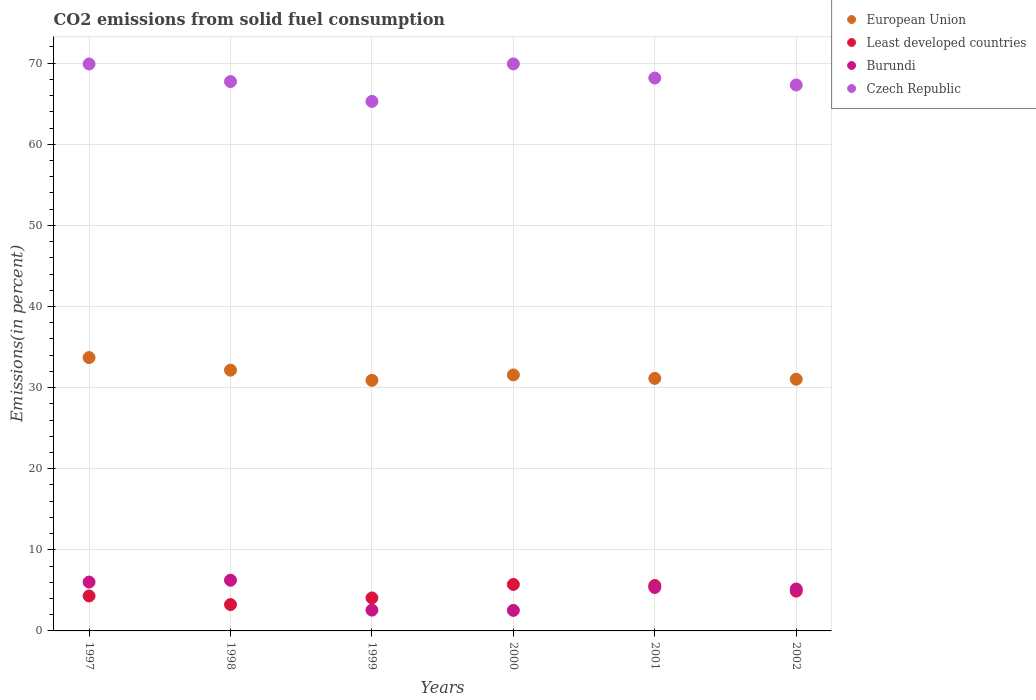How many different coloured dotlines are there?
Provide a short and direct response. 4. What is the total CO2 emitted in Czech Republic in 1997?
Ensure brevity in your answer.  69.9. Across all years, what is the maximum total CO2 emitted in Czech Republic?
Offer a terse response. 69.91. Across all years, what is the minimum total CO2 emitted in Least developed countries?
Provide a succinct answer. 3.25. What is the total total CO2 emitted in European Union in the graph?
Your response must be concise. 190.49. What is the difference between the total CO2 emitted in Least developed countries in 1998 and that in 1999?
Your answer should be compact. -0.82. What is the difference between the total CO2 emitted in Czech Republic in 2002 and the total CO2 emitted in Burundi in 2001?
Provide a succinct answer. 61.96. What is the average total CO2 emitted in European Union per year?
Your answer should be compact. 31.75. In the year 2000, what is the difference between the total CO2 emitted in European Union and total CO2 emitted in Czech Republic?
Your answer should be compact. -38.35. In how many years, is the total CO2 emitted in Czech Republic greater than 66 %?
Keep it short and to the point. 5. What is the ratio of the total CO2 emitted in Czech Republic in 2000 to that in 2002?
Your answer should be very brief. 1.04. What is the difference between the highest and the second highest total CO2 emitted in Least developed countries?
Your response must be concise. 0.13. What is the difference between the highest and the lowest total CO2 emitted in Czech Republic?
Ensure brevity in your answer.  4.62. In how many years, is the total CO2 emitted in Burundi greater than the average total CO2 emitted in Burundi taken over all years?
Offer a very short reply. 4. Is the sum of the total CO2 emitted in European Union in 1999 and 2002 greater than the maximum total CO2 emitted in Burundi across all years?
Keep it short and to the point. Yes. Is it the case that in every year, the sum of the total CO2 emitted in Least developed countries and total CO2 emitted in Burundi  is greater than the sum of total CO2 emitted in Czech Republic and total CO2 emitted in European Union?
Your response must be concise. No. Is the total CO2 emitted in Burundi strictly greater than the total CO2 emitted in Czech Republic over the years?
Your answer should be compact. No. Is the total CO2 emitted in Least developed countries strictly less than the total CO2 emitted in Czech Republic over the years?
Your response must be concise. Yes. Are the values on the major ticks of Y-axis written in scientific E-notation?
Make the answer very short. No. Does the graph contain any zero values?
Provide a short and direct response. No. How many legend labels are there?
Offer a terse response. 4. What is the title of the graph?
Offer a terse response. CO2 emissions from solid fuel consumption. What is the label or title of the Y-axis?
Make the answer very short. Emissions(in percent). What is the Emissions(in percent) in European Union in 1997?
Give a very brief answer. 33.7. What is the Emissions(in percent) in Least developed countries in 1997?
Keep it short and to the point. 4.31. What is the Emissions(in percent) in Burundi in 1997?
Ensure brevity in your answer.  6.02. What is the Emissions(in percent) of Czech Republic in 1997?
Offer a very short reply. 69.9. What is the Emissions(in percent) in European Union in 1998?
Your answer should be very brief. 32.15. What is the Emissions(in percent) in Least developed countries in 1998?
Your response must be concise. 3.25. What is the Emissions(in percent) of Burundi in 1998?
Make the answer very short. 6.25. What is the Emissions(in percent) in Czech Republic in 1998?
Your answer should be very brief. 67.73. What is the Emissions(in percent) in European Union in 1999?
Give a very brief answer. 30.9. What is the Emissions(in percent) in Least developed countries in 1999?
Ensure brevity in your answer.  4.07. What is the Emissions(in percent) of Burundi in 1999?
Give a very brief answer. 2.56. What is the Emissions(in percent) in Czech Republic in 1999?
Your answer should be very brief. 65.29. What is the Emissions(in percent) of European Union in 2000?
Offer a very short reply. 31.56. What is the Emissions(in percent) of Least developed countries in 2000?
Your response must be concise. 5.73. What is the Emissions(in percent) in Burundi in 2000?
Provide a succinct answer. 2.53. What is the Emissions(in percent) of Czech Republic in 2000?
Offer a very short reply. 69.91. What is the Emissions(in percent) in European Union in 2001?
Ensure brevity in your answer.  31.14. What is the Emissions(in percent) in Least developed countries in 2001?
Ensure brevity in your answer.  5.6. What is the Emissions(in percent) in Burundi in 2001?
Your answer should be compact. 5.36. What is the Emissions(in percent) of Czech Republic in 2001?
Make the answer very short. 68.17. What is the Emissions(in percent) of European Union in 2002?
Provide a short and direct response. 31.04. What is the Emissions(in percent) of Least developed countries in 2002?
Make the answer very short. 4.91. What is the Emissions(in percent) in Burundi in 2002?
Offer a terse response. 5.17. What is the Emissions(in percent) of Czech Republic in 2002?
Your answer should be compact. 67.31. Across all years, what is the maximum Emissions(in percent) of European Union?
Ensure brevity in your answer.  33.7. Across all years, what is the maximum Emissions(in percent) in Least developed countries?
Ensure brevity in your answer.  5.73. Across all years, what is the maximum Emissions(in percent) of Burundi?
Provide a succinct answer. 6.25. Across all years, what is the maximum Emissions(in percent) of Czech Republic?
Your answer should be compact. 69.91. Across all years, what is the minimum Emissions(in percent) in European Union?
Make the answer very short. 30.9. Across all years, what is the minimum Emissions(in percent) in Least developed countries?
Give a very brief answer. 3.25. Across all years, what is the minimum Emissions(in percent) of Burundi?
Your answer should be very brief. 2.53. Across all years, what is the minimum Emissions(in percent) in Czech Republic?
Your answer should be compact. 65.29. What is the total Emissions(in percent) of European Union in the graph?
Your response must be concise. 190.49. What is the total Emissions(in percent) of Least developed countries in the graph?
Keep it short and to the point. 27.86. What is the total Emissions(in percent) in Burundi in the graph?
Give a very brief answer. 27.9. What is the total Emissions(in percent) of Czech Republic in the graph?
Ensure brevity in your answer.  408.32. What is the difference between the Emissions(in percent) of European Union in 1997 and that in 1998?
Your answer should be compact. 1.55. What is the difference between the Emissions(in percent) in Least developed countries in 1997 and that in 1998?
Your response must be concise. 1.06. What is the difference between the Emissions(in percent) of Burundi in 1997 and that in 1998?
Give a very brief answer. -0.23. What is the difference between the Emissions(in percent) of Czech Republic in 1997 and that in 1998?
Give a very brief answer. 2.17. What is the difference between the Emissions(in percent) in European Union in 1997 and that in 1999?
Provide a succinct answer. 2.8. What is the difference between the Emissions(in percent) in Least developed countries in 1997 and that in 1999?
Offer a very short reply. 0.25. What is the difference between the Emissions(in percent) of Burundi in 1997 and that in 1999?
Keep it short and to the point. 3.46. What is the difference between the Emissions(in percent) in Czech Republic in 1997 and that in 1999?
Your answer should be very brief. 4.61. What is the difference between the Emissions(in percent) of European Union in 1997 and that in 2000?
Your response must be concise. 2.14. What is the difference between the Emissions(in percent) of Least developed countries in 1997 and that in 2000?
Provide a succinct answer. -1.42. What is the difference between the Emissions(in percent) in Burundi in 1997 and that in 2000?
Your answer should be compact. 3.49. What is the difference between the Emissions(in percent) of Czech Republic in 1997 and that in 2000?
Your response must be concise. -0.01. What is the difference between the Emissions(in percent) of European Union in 1997 and that in 2001?
Keep it short and to the point. 2.56. What is the difference between the Emissions(in percent) of Least developed countries in 1997 and that in 2001?
Provide a short and direct response. -1.29. What is the difference between the Emissions(in percent) of Burundi in 1997 and that in 2001?
Provide a short and direct response. 0.67. What is the difference between the Emissions(in percent) of Czech Republic in 1997 and that in 2001?
Offer a very short reply. 1.73. What is the difference between the Emissions(in percent) in European Union in 1997 and that in 2002?
Your answer should be very brief. 2.67. What is the difference between the Emissions(in percent) of Least developed countries in 1997 and that in 2002?
Give a very brief answer. -0.6. What is the difference between the Emissions(in percent) of Burundi in 1997 and that in 2002?
Make the answer very short. 0.85. What is the difference between the Emissions(in percent) of Czech Republic in 1997 and that in 2002?
Make the answer very short. 2.59. What is the difference between the Emissions(in percent) of European Union in 1998 and that in 1999?
Make the answer very short. 1.26. What is the difference between the Emissions(in percent) in Least developed countries in 1998 and that in 1999?
Give a very brief answer. -0.82. What is the difference between the Emissions(in percent) of Burundi in 1998 and that in 1999?
Offer a very short reply. 3.69. What is the difference between the Emissions(in percent) of Czech Republic in 1998 and that in 1999?
Your answer should be very brief. 2.45. What is the difference between the Emissions(in percent) in European Union in 1998 and that in 2000?
Your answer should be very brief. 0.59. What is the difference between the Emissions(in percent) in Least developed countries in 1998 and that in 2000?
Give a very brief answer. -2.48. What is the difference between the Emissions(in percent) in Burundi in 1998 and that in 2000?
Give a very brief answer. 3.72. What is the difference between the Emissions(in percent) in Czech Republic in 1998 and that in 2000?
Offer a very short reply. -2.18. What is the difference between the Emissions(in percent) in European Union in 1998 and that in 2001?
Your response must be concise. 1.02. What is the difference between the Emissions(in percent) of Least developed countries in 1998 and that in 2001?
Offer a terse response. -2.35. What is the difference between the Emissions(in percent) in Burundi in 1998 and that in 2001?
Make the answer very short. 0.89. What is the difference between the Emissions(in percent) in Czech Republic in 1998 and that in 2001?
Your answer should be very brief. -0.44. What is the difference between the Emissions(in percent) of European Union in 1998 and that in 2002?
Provide a short and direct response. 1.12. What is the difference between the Emissions(in percent) in Least developed countries in 1998 and that in 2002?
Offer a terse response. -1.66. What is the difference between the Emissions(in percent) of Burundi in 1998 and that in 2002?
Ensure brevity in your answer.  1.08. What is the difference between the Emissions(in percent) in Czech Republic in 1998 and that in 2002?
Keep it short and to the point. 0.42. What is the difference between the Emissions(in percent) of Least developed countries in 1999 and that in 2000?
Provide a succinct answer. -1.66. What is the difference between the Emissions(in percent) of Burundi in 1999 and that in 2000?
Provide a short and direct response. 0.03. What is the difference between the Emissions(in percent) in Czech Republic in 1999 and that in 2000?
Keep it short and to the point. -4.62. What is the difference between the Emissions(in percent) of European Union in 1999 and that in 2001?
Offer a terse response. -0.24. What is the difference between the Emissions(in percent) in Least developed countries in 1999 and that in 2001?
Offer a terse response. -1.53. What is the difference between the Emissions(in percent) of Burundi in 1999 and that in 2001?
Make the answer very short. -2.79. What is the difference between the Emissions(in percent) of Czech Republic in 1999 and that in 2001?
Keep it short and to the point. -2.88. What is the difference between the Emissions(in percent) in European Union in 1999 and that in 2002?
Offer a very short reply. -0.14. What is the difference between the Emissions(in percent) of Least developed countries in 1999 and that in 2002?
Keep it short and to the point. -0.84. What is the difference between the Emissions(in percent) in Burundi in 1999 and that in 2002?
Your response must be concise. -2.61. What is the difference between the Emissions(in percent) of Czech Republic in 1999 and that in 2002?
Make the answer very short. -2.03. What is the difference between the Emissions(in percent) of European Union in 2000 and that in 2001?
Offer a terse response. 0.43. What is the difference between the Emissions(in percent) in Least developed countries in 2000 and that in 2001?
Make the answer very short. 0.13. What is the difference between the Emissions(in percent) of Burundi in 2000 and that in 2001?
Give a very brief answer. -2.83. What is the difference between the Emissions(in percent) of Czech Republic in 2000 and that in 2001?
Provide a short and direct response. 1.74. What is the difference between the Emissions(in percent) of European Union in 2000 and that in 2002?
Offer a very short reply. 0.53. What is the difference between the Emissions(in percent) of Least developed countries in 2000 and that in 2002?
Offer a very short reply. 0.82. What is the difference between the Emissions(in percent) in Burundi in 2000 and that in 2002?
Your answer should be very brief. -2.64. What is the difference between the Emissions(in percent) in Czech Republic in 2000 and that in 2002?
Keep it short and to the point. 2.6. What is the difference between the Emissions(in percent) of European Union in 2001 and that in 2002?
Keep it short and to the point. 0.1. What is the difference between the Emissions(in percent) in Least developed countries in 2001 and that in 2002?
Provide a short and direct response. 0.69. What is the difference between the Emissions(in percent) of Burundi in 2001 and that in 2002?
Make the answer very short. 0.18. What is the difference between the Emissions(in percent) in Czech Republic in 2001 and that in 2002?
Your answer should be compact. 0.86. What is the difference between the Emissions(in percent) in European Union in 1997 and the Emissions(in percent) in Least developed countries in 1998?
Keep it short and to the point. 30.45. What is the difference between the Emissions(in percent) in European Union in 1997 and the Emissions(in percent) in Burundi in 1998?
Your response must be concise. 27.45. What is the difference between the Emissions(in percent) of European Union in 1997 and the Emissions(in percent) of Czech Republic in 1998?
Offer a very short reply. -34.03. What is the difference between the Emissions(in percent) of Least developed countries in 1997 and the Emissions(in percent) of Burundi in 1998?
Your answer should be very brief. -1.94. What is the difference between the Emissions(in percent) of Least developed countries in 1997 and the Emissions(in percent) of Czech Republic in 1998?
Your answer should be very brief. -63.42. What is the difference between the Emissions(in percent) of Burundi in 1997 and the Emissions(in percent) of Czech Republic in 1998?
Your response must be concise. -61.71. What is the difference between the Emissions(in percent) in European Union in 1997 and the Emissions(in percent) in Least developed countries in 1999?
Give a very brief answer. 29.64. What is the difference between the Emissions(in percent) of European Union in 1997 and the Emissions(in percent) of Burundi in 1999?
Keep it short and to the point. 31.14. What is the difference between the Emissions(in percent) of European Union in 1997 and the Emissions(in percent) of Czech Republic in 1999?
Give a very brief answer. -31.59. What is the difference between the Emissions(in percent) in Least developed countries in 1997 and the Emissions(in percent) in Burundi in 1999?
Offer a very short reply. 1.75. What is the difference between the Emissions(in percent) in Least developed countries in 1997 and the Emissions(in percent) in Czech Republic in 1999?
Provide a short and direct response. -60.98. What is the difference between the Emissions(in percent) of Burundi in 1997 and the Emissions(in percent) of Czech Republic in 1999?
Make the answer very short. -59.26. What is the difference between the Emissions(in percent) of European Union in 1997 and the Emissions(in percent) of Least developed countries in 2000?
Give a very brief answer. 27.97. What is the difference between the Emissions(in percent) of European Union in 1997 and the Emissions(in percent) of Burundi in 2000?
Provide a succinct answer. 31.17. What is the difference between the Emissions(in percent) in European Union in 1997 and the Emissions(in percent) in Czech Republic in 2000?
Ensure brevity in your answer.  -36.21. What is the difference between the Emissions(in percent) of Least developed countries in 1997 and the Emissions(in percent) of Burundi in 2000?
Make the answer very short. 1.78. What is the difference between the Emissions(in percent) in Least developed countries in 1997 and the Emissions(in percent) in Czech Republic in 2000?
Provide a succinct answer. -65.6. What is the difference between the Emissions(in percent) of Burundi in 1997 and the Emissions(in percent) of Czech Republic in 2000?
Provide a short and direct response. -63.89. What is the difference between the Emissions(in percent) in European Union in 1997 and the Emissions(in percent) in Least developed countries in 2001?
Your response must be concise. 28.1. What is the difference between the Emissions(in percent) in European Union in 1997 and the Emissions(in percent) in Burundi in 2001?
Your answer should be compact. 28.35. What is the difference between the Emissions(in percent) in European Union in 1997 and the Emissions(in percent) in Czech Republic in 2001?
Offer a very short reply. -34.47. What is the difference between the Emissions(in percent) in Least developed countries in 1997 and the Emissions(in percent) in Burundi in 2001?
Your answer should be compact. -1.05. What is the difference between the Emissions(in percent) of Least developed countries in 1997 and the Emissions(in percent) of Czech Republic in 2001?
Provide a succinct answer. -63.86. What is the difference between the Emissions(in percent) in Burundi in 1997 and the Emissions(in percent) in Czech Republic in 2001?
Offer a terse response. -62.15. What is the difference between the Emissions(in percent) of European Union in 1997 and the Emissions(in percent) of Least developed countries in 2002?
Provide a succinct answer. 28.79. What is the difference between the Emissions(in percent) in European Union in 1997 and the Emissions(in percent) in Burundi in 2002?
Ensure brevity in your answer.  28.53. What is the difference between the Emissions(in percent) of European Union in 1997 and the Emissions(in percent) of Czech Republic in 2002?
Provide a short and direct response. -33.61. What is the difference between the Emissions(in percent) of Least developed countries in 1997 and the Emissions(in percent) of Burundi in 2002?
Offer a terse response. -0.86. What is the difference between the Emissions(in percent) of Least developed countries in 1997 and the Emissions(in percent) of Czech Republic in 2002?
Give a very brief answer. -63. What is the difference between the Emissions(in percent) of Burundi in 1997 and the Emissions(in percent) of Czech Republic in 2002?
Give a very brief answer. -61.29. What is the difference between the Emissions(in percent) of European Union in 1998 and the Emissions(in percent) of Least developed countries in 1999?
Offer a very short reply. 28.09. What is the difference between the Emissions(in percent) in European Union in 1998 and the Emissions(in percent) in Burundi in 1999?
Your response must be concise. 29.59. What is the difference between the Emissions(in percent) in European Union in 1998 and the Emissions(in percent) in Czech Republic in 1999?
Keep it short and to the point. -33.14. What is the difference between the Emissions(in percent) in Least developed countries in 1998 and the Emissions(in percent) in Burundi in 1999?
Offer a terse response. 0.68. What is the difference between the Emissions(in percent) of Least developed countries in 1998 and the Emissions(in percent) of Czech Republic in 1999?
Your answer should be compact. -62.04. What is the difference between the Emissions(in percent) in Burundi in 1998 and the Emissions(in percent) in Czech Republic in 1999?
Provide a succinct answer. -59.04. What is the difference between the Emissions(in percent) in European Union in 1998 and the Emissions(in percent) in Least developed countries in 2000?
Make the answer very short. 26.42. What is the difference between the Emissions(in percent) of European Union in 1998 and the Emissions(in percent) of Burundi in 2000?
Your answer should be very brief. 29.62. What is the difference between the Emissions(in percent) of European Union in 1998 and the Emissions(in percent) of Czech Republic in 2000?
Offer a very short reply. -37.76. What is the difference between the Emissions(in percent) in Least developed countries in 1998 and the Emissions(in percent) in Burundi in 2000?
Offer a terse response. 0.72. What is the difference between the Emissions(in percent) in Least developed countries in 1998 and the Emissions(in percent) in Czech Republic in 2000?
Make the answer very short. -66.67. What is the difference between the Emissions(in percent) in Burundi in 1998 and the Emissions(in percent) in Czech Republic in 2000?
Offer a terse response. -63.66. What is the difference between the Emissions(in percent) of European Union in 1998 and the Emissions(in percent) of Least developed countries in 2001?
Keep it short and to the point. 26.55. What is the difference between the Emissions(in percent) of European Union in 1998 and the Emissions(in percent) of Burundi in 2001?
Make the answer very short. 26.8. What is the difference between the Emissions(in percent) of European Union in 1998 and the Emissions(in percent) of Czech Republic in 2001?
Give a very brief answer. -36.02. What is the difference between the Emissions(in percent) of Least developed countries in 1998 and the Emissions(in percent) of Burundi in 2001?
Provide a succinct answer. -2.11. What is the difference between the Emissions(in percent) of Least developed countries in 1998 and the Emissions(in percent) of Czech Republic in 2001?
Offer a terse response. -64.92. What is the difference between the Emissions(in percent) in Burundi in 1998 and the Emissions(in percent) in Czech Republic in 2001?
Give a very brief answer. -61.92. What is the difference between the Emissions(in percent) of European Union in 1998 and the Emissions(in percent) of Least developed countries in 2002?
Keep it short and to the point. 27.25. What is the difference between the Emissions(in percent) in European Union in 1998 and the Emissions(in percent) in Burundi in 2002?
Provide a short and direct response. 26.98. What is the difference between the Emissions(in percent) of European Union in 1998 and the Emissions(in percent) of Czech Republic in 2002?
Offer a very short reply. -35.16. What is the difference between the Emissions(in percent) of Least developed countries in 1998 and the Emissions(in percent) of Burundi in 2002?
Your response must be concise. -1.92. What is the difference between the Emissions(in percent) in Least developed countries in 1998 and the Emissions(in percent) in Czech Republic in 2002?
Ensure brevity in your answer.  -64.07. What is the difference between the Emissions(in percent) of Burundi in 1998 and the Emissions(in percent) of Czech Republic in 2002?
Offer a terse response. -61.06. What is the difference between the Emissions(in percent) of European Union in 1999 and the Emissions(in percent) of Least developed countries in 2000?
Give a very brief answer. 25.17. What is the difference between the Emissions(in percent) of European Union in 1999 and the Emissions(in percent) of Burundi in 2000?
Provide a succinct answer. 28.37. What is the difference between the Emissions(in percent) of European Union in 1999 and the Emissions(in percent) of Czech Republic in 2000?
Keep it short and to the point. -39.02. What is the difference between the Emissions(in percent) in Least developed countries in 1999 and the Emissions(in percent) in Burundi in 2000?
Offer a very short reply. 1.53. What is the difference between the Emissions(in percent) of Least developed countries in 1999 and the Emissions(in percent) of Czech Republic in 2000?
Provide a short and direct response. -65.85. What is the difference between the Emissions(in percent) in Burundi in 1999 and the Emissions(in percent) in Czech Republic in 2000?
Provide a short and direct response. -67.35. What is the difference between the Emissions(in percent) of European Union in 1999 and the Emissions(in percent) of Least developed countries in 2001?
Provide a short and direct response. 25.3. What is the difference between the Emissions(in percent) in European Union in 1999 and the Emissions(in percent) in Burundi in 2001?
Your answer should be very brief. 25.54. What is the difference between the Emissions(in percent) in European Union in 1999 and the Emissions(in percent) in Czech Republic in 2001?
Provide a short and direct response. -37.27. What is the difference between the Emissions(in percent) in Least developed countries in 1999 and the Emissions(in percent) in Burundi in 2001?
Offer a terse response. -1.29. What is the difference between the Emissions(in percent) of Least developed countries in 1999 and the Emissions(in percent) of Czech Republic in 2001?
Your answer should be compact. -64.11. What is the difference between the Emissions(in percent) in Burundi in 1999 and the Emissions(in percent) in Czech Republic in 2001?
Ensure brevity in your answer.  -65.61. What is the difference between the Emissions(in percent) in European Union in 1999 and the Emissions(in percent) in Least developed countries in 2002?
Provide a succinct answer. 25.99. What is the difference between the Emissions(in percent) in European Union in 1999 and the Emissions(in percent) in Burundi in 2002?
Keep it short and to the point. 25.73. What is the difference between the Emissions(in percent) of European Union in 1999 and the Emissions(in percent) of Czech Republic in 2002?
Offer a terse response. -36.42. What is the difference between the Emissions(in percent) in Least developed countries in 1999 and the Emissions(in percent) in Burundi in 2002?
Your answer should be compact. -1.11. What is the difference between the Emissions(in percent) in Least developed countries in 1999 and the Emissions(in percent) in Czech Republic in 2002?
Your answer should be very brief. -63.25. What is the difference between the Emissions(in percent) in Burundi in 1999 and the Emissions(in percent) in Czech Republic in 2002?
Make the answer very short. -64.75. What is the difference between the Emissions(in percent) in European Union in 2000 and the Emissions(in percent) in Least developed countries in 2001?
Provide a short and direct response. 25.97. What is the difference between the Emissions(in percent) in European Union in 2000 and the Emissions(in percent) in Burundi in 2001?
Keep it short and to the point. 26.21. What is the difference between the Emissions(in percent) in European Union in 2000 and the Emissions(in percent) in Czech Republic in 2001?
Your answer should be very brief. -36.61. What is the difference between the Emissions(in percent) in Least developed countries in 2000 and the Emissions(in percent) in Burundi in 2001?
Give a very brief answer. 0.37. What is the difference between the Emissions(in percent) in Least developed countries in 2000 and the Emissions(in percent) in Czech Republic in 2001?
Keep it short and to the point. -62.44. What is the difference between the Emissions(in percent) in Burundi in 2000 and the Emissions(in percent) in Czech Republic in 2001?
Give a very brief answer. -65.64. What is the difference between the Emissions(in percent) in European Union in 2000 and the Emissions(in percent) in Least developed countries in 2002?
Ensure brevity in your answer.  26.66. What is the difference between the Emissions(in percent) in European Union in 2000 and the Emissions(in percent) in Burundi in 2002?
Your response must be concise. 26.39. What is the difference between the Emissions(in percent) of European Union in 2000 and the Emissions(in percent) of Czech Republic in 2002?
Provide a succinct answer. -35.75. What is the difference between the Emissions(in percent) of Least developed countries in 2000 and the Emissions(in percent) of Burundi in 2002?
Provide a succinct answer. 0.56. What is the difference between the Emissions(in percent) of Least developed countries in 2000 and the Emissions(in percent) of Czech Republic in 2002?
Offer a very short reply. -61.59. What is the difference between the Emissions(in percent) of Burundi in 2000 and the Emissions(in percent) of Czech Republic in 2002?
Give a very brief answer. -64.78. What is the difference between the Emissions(in percent) of European Union in 2001 and the Emissions(in percent) of Least developed countries in 2002?
Make the answer very short. 26.23. What is the difference between the Emissions(in percent) of European Union in 2001 and the Emissions(in percent) of Burundi in 2002?
Your answer should be compact. 25.97. What is the difference between the Emissions(in percent) in European Union in 2001 and the Emissions(in percent) in Czech Republic in 2002?
Your answer should be very brief. -36.18. What is the difference between the Emissions(in percent) in Least developed countries in 2001 and the Emissions(in percent) in Burundi in 2002?
Make the answer very short. 0.43. What is the difference between the Emissions(in percent) of Least developed countries in 2001 and the Emissions(in percent) of Czech Republic in 2002?
Give a very brief answer. -61.72. What is the difference between the Emissions(in percent) of Burundi in 2001 and the Emissions(in percent) of Czech Republic in 2002?
Keep it short and to the point. -61.96. What is the average Emissions(in percent) of European Union per year?
Your answer should be very brief. 31.75. What is the average Emissions(in percent) of Least developed countries per year?
Provide a succinct answer. 4.64. What is the average Emissions(in percent) in Burundi per year?
Offer a terse response. 4.65. What is the average Emissions(in percent) in Czech Republic per year?
Give a very brief answer. 68.05. In the year 1997, what is the difference between the Emissions(in percent) in European Union and Emissions(in percent) in Least developed countries?
Your answer should be compact. 29.39. In the year 1997, what is the difference between the Emissions(in percent) in European Union and Emissions(in percent) in Burundi?
Keep it short and to the point. 27.68. In the year 1997, what is the difference between the Emissions(in percent) in European Union and Emissions(in percent) in Czech Republic?
Offer a very short reply. -36.2. In the year 1997, what is the difference between the Emissions(in percent) of Least developed countries and Emissions(in percent) of Burundi?
Provide a short and direct response. -1.71. In the year 1997, what is the difference between the Emissions(in percent) in Least developed countries and Emissions(in percent) in Czech Republic?
Give a very brief answer. -65.59. In the year 1997, what is the difference between the Emissions(in percent) of Burundi and Emissions(in percent) of Czech Republic?
Your response must be concise. -63.88. In the year 1998, what is the difference between the Emissions(in percent) of European Union and Emissions(in percent) of Least developed countries?
Provide a succinct answer. 28.91. In the year 1998, what is the difference between the Emissions(in percent) in European Union and Emissions(in percent) in Burundi?
Ensure brevity in your answer.  25.9. In the year 1998, what is the difference between the Emissions(in percent) in European Union and Emissions(in percent) in Czech Republic?
Offer a terse response. -35.58. In the year 1998, what is the difference between the Emissions(in percent) in Least developed countries and Emissions(in percent) in Burundi?
Offer a terse response. -3. In the year 1998, what is the difference between the Emissions(in percent) of Least developed countries and Emissions(in percent) of Czech Republic?
Your answer should be very brief. -64.49. In the year 1998, what is the difference between the Emissions(in percent) of Burundi and Emissions(in percent) of Czech Republic?
Give a very brief answer. -61.48. In the year 1999, what is the difference between the Emissions(in percent) in European Union and Emissions(in percent) in Least developed countries?
Your answer should be compact. 26.83. In the year 1999, what is the difference between the Emissions(in percent) in European Union and Emissions(in percent) in Burundi?
Offer a very short reply. 28.33. In the year 1999, what is the difference between the Emissions(in percent) of European Union and Emissions(in percent) of Czech Republic?
Ensure brevity in your answer.  -34.39. In the year 1999, what is the difference between the Emissions(in percent) of Least developed countries and Emissions(in percent) of Burundi?
Keep it short and to the point. 1.5. In the year 1999, what is the difference between the Emissions(in percent) of Least developed countries and Emissions(in percent) of Czech Republic?
Keep it short and to the point. -61.22. In the year 1999, what is the difference between the Emissions(in percent) of Burundi and Emissions(in percent) of Czech Republic?
Your answer should be very brief. -62.72. In the year 2000, what is the difference between the Emissions(in percent) in European Union and Emissions(in percent) in Least developed countries?
Keep it short and to the point. 25.83. In the year 2000, what is the difference between the Emissions(in percent) of European Union and Emissions(in percent) of Burundi?
Your response must be concise. 29.03. In the year 2000, what is the difference between the Emissions(in percent) in European Union and Emissions(in percent) in Czech Republic?
Offer a very short reply. -38.35. In the year 2000, what is the difference between the Emissions(in percent) in Least developed countries and Emissions(in percent) in Burundi?
Your answer should be very brief. 3.2. In the year 2000, what is the difference between the Emissions(in percent) of Least developed countries and Emissions(in percent) of Czech Republic?
Your answer should be very brief. -64.18. In the year 2000, what is the difference between the Emissions(in percent) in Burundi and Emissions(in percent) in Czech Republic?
Give a very brief answer. -67.38. In the year 2001, what is the difference between the Emissions(in percent) in European Union and Emissions(in percent) in Least developed countries?
Provide a short and direct response. 25.54. In the year 2001, what is the difference between the Emissions(in percent) in European Union and Emissions(in percent) in Burundi?
Provide a succinct answer. 25.78. In the year 2001, what is the difference between the Emissions(in percent) in European Union and Emissions(in percent) in Czech Republic?
Offer a terse response. -37.03. In the year 2001, what is the difference between the Emissions(in percent) of Least developed countries and Emissions(in percent) of Burundi?
Provide a short and direct response. 0.24. In the year 2001, what is the difference between the Emissions(in percent) of Least developed countries and Emissions(in percent) of Czech Republic?
Make the answer very short. -62.57. In the year 2001, what is the difference between the Emissions(in percent) in Burundi and Emissions(in percent) in Czech Republic?
Provide a succinct answer. -62.81. In the year 2002, what is the difference between the Emissions(in percent) of European Union and Emissions(in percent) of Least developed countries?
Offer a very short reply. 26.13. In the year 2002, what is the difference between the Emissions(in percent) of European Union and Emissions(in percent) of Burundi?
Give a very brief answer. 25.86. In the year 2002, what is the difference between the Emissions(in percent) in European Union and Emissions(in percent) in Czech Republic?
Offer a terse response. -36.28. In the year 2002, what is the difference between the Emissions(in percent) of Least developed countries and Emissions(in percent) of Burundi?
Make the answer very short. -0.26. In the year 2002, what is the difference between the Emissions(in percent) in Least developed countries and Emissions(in percent) in Czech Republic?
Provide a succinct answer. -62.41. In the year 2002, what is the difference between the Emissions(in percent) in Burundi and Emissions(in percent) in Czech Republic?
Offer a very short reply. -62.14. What is the ratio of the Emissions(in percent) in European Union in 1997 to that in 1998?
Provide a succinct answer. 1.05. What is the ratio of the Emissions(in percent) of Least developed countries in 1997 to that in 1998?
Offer a terse response. 1.33. What is the ratio of the Emissions(in percent) in Burundi in 1997 to that in 1998?
Your answer should be very brief. 0.96. What is the ratio of the Emissions(in percent) in Czech Republic in 1997 to that in 1998?
Make the answer very short. 1.03. What is the ratio of the Emissions(in percent) in European Union in 1997 to that in 1999?
Keep it short and to the point. 1.09. What is the ratio of the Emissions(in percent) in Least developed countries in 1997 to that in 1999?
Give a very brief answer. 1.06. What is the ratio of the Emissions(in percent) of Burundi in 1997 to that in 1999?
Offer a very short reply. 2.35. What is the ratio of the Emissions(in percent) in Czech Republic in 1997 to that in 1999?
Provide a succinct answer. 1.07. What is the ratio of the Emissions(in percent) of European Union in 1997 to that in 2000?
Your answer should be compact. 1.07. What is the ratio of the Emissions(in percent) in Least developed countries in 1997 to that in 2000?
Provide a short and direct response. 0.75. What is the ratio of the Emissions(in percent) of Burundi in 1997 to that in 2000?
Offer a very short reply. 2.38. What is the ratio of the Emissions(in percent) in Czech Republic in 1997 to that in 2000?
Keep it short and to the point. 1. What is the ratio of the Emissions(in percent) in European Union in 1997 to that in 2001?
Offer a terse response. 1.08. What is the ratio of the Emissions(in percent) in Least developed countries in 1997 to that in 2001?
Provide a short and direct response. 0.77. What is the ratio of the Emissions(in percent) of Burundi in 1997 to that in 2001?
Provide a short and direct response. 1.12. What is the ratio of the Emissions(in percent) in Czech Republic in 1997 to that in 2001?
Offer a very short reply. 1.03. What is the ratio of the Emissions(in percent) of European Union in 1997 to that in 2002?
Provide a succinct answer. 1.09. What is the ratio of the Emissions(in percent) in Least developed countries in 1997 to that in 2002?
Your answer should be very brief. 0.88. What is the ratio of the Emissions(in percent) in Burundi in 1997 to that in 2002?
Provide a succinct answer. 1.16. What is the ratio of the Emissions(in percent) in Czech Republic in 1997 to that in 2002?
Offer a very short reply. 1.04. What is the ratio of the Emissions(in percent) of European Union in 1998 to that in 1999?
Your answer should be compact. 1.04. What is the ratio of the Emissions(in percent) in Least developed countries in 1998 to that in 1999?
Make the answer very short. 0.8. What is the ratio of the Emissions(in percent) in Burundi in 1998 to that in 1999?
Provide a succinct answer. 2.44. What is the ratio of the Emissions(in percent) in Czech Republic in 1998 to that in 1999?
Offer a very short reply. 1.04. What is the ratio of the Emissions(in percent) of European Union in 1998 to that in 2000?
Make the answer very short. 1.02. What is the ratio of the Emissions(in percent) in Least developed countries in 1998 to that in 2000?
Keep it short and to the point. 0.57. What is the ratio of the Emissions(in percent) of Burundi in 1998 to that in 2000?
Ensure brevity in your answer.  2.47. What is the ratio of the Emissions(in percent) of Czech Republic in 1998 to that in 2000?
Ensure brevity in your answer.  0.97. What is the ratio of the Emissions(in percent) in European Union in 1998 to that in 2001?
Provide a succinct answer. 1.03. What is the ratio of the Emissions(in percent) of Least developed countries in 1998 to that in 2001?
Make the answer very short. 0.58. What is the ratio of the Emissions(in percent) in Burundi in 1998 to that in 2001?
Offer a terse response. 1.17. What is the ratio of the Emissions(in percent) of European Union in 1998 to that in 2002?
Keep it short and to the point. 1.04. What is the ratio of the Emissions(in percent) in Least developed countries in 1998 to that in 2002?
Provide a succinct answer. 0.66. What is the ratio of the Emissions(in percent) of Burundi in 1998 to that in 2002?
Your response must be concise. 1.21. What is the ratio of the Emissions(in percent) of Czech Republic in 1998 to that in 2002?
Your response must be concise. 1.01. What is the ratio of the Emissions(in percent) in European Union in 1999 to that in 2000?
Offer a terse response. 0.98. What is the ratio of the Emissions(in percent) in Least developed countries in 1999 to that in 2000?
Ensure brevity in your answer.  0.71. What is the ratio of the Emissions(in percent) in Burundi in 1999 to that in 2000?
Make the answer very short. 1.01. What is the ratio of the Emissions(in percent) in Czech Republic in 1999 to that in 2000?
Give a very brief answer. 0.93. What is the ratio of the Emissions(in percent) in Least developed countries in 1999 to that in 2001?
Provide a short and direct response. 0.73. What is the ratio of the Emissions(in percent) in Burundi in 1999 to that in 2001?
Provide a succinct answer. 0.48. What is the ratio of the Emissions(in percent) in Czech Republic in 1999 to that in 2001?
Provide a short and direct response. 0.96. What is the ratio of the Emissions(in percent) in Least developed countries in 1999 to that in 2002?
Offer a very short reply. 0.83. What is the ratio of the Emissions(in percent) in Burundi in 1999 to that in 2002?
Offer a very short reply. 0.5. What is the ratio of the Emissions(in percent) of Czech Republic in 1999 to that in 2002?
Offer a terse response. 0.97. What is the ratio of the Emissions(in percent) of European Union in 2000 to that in 2001?
Your answer should be very brief. 1.01. What is the ratio of the Emissions(in percent) in Least developed countries in 2000 to that in 2001?
Give a very brief answer. 1.02. What is the ratio of the Emissions(in percent) in Burundi in 2000 to that in 2001?
Your answer should be very brief. 0.47. What is the ratio of the Emissions(in percent) in Czech Republic in 2000 to that in 2001?
Provide a short and direct response. 1.03. What is the ratio of the Emissions(in percent) in European Union in 2000 to that in 2002?
Provide a succinct answer. 1.02. What is the ratio of the Emissions(in percent) of Least developed countries in 2000 to that in 2002?
Offer a terse response. 1.17. What is the ratio of the Emissions(in percent) in Burundi in 2000 to that in 2002?
Make the answer very short. 0.49. What is the ratio of the Emissions(in percent) of Czech Republic in 2000 to that in 2002?
Your answer should be very brief. 1.04. What is the ratio of the Emissions(in percent) of European Union in 2001 to that in 2002?
Ensure brevity in your answer.  1. What is the ratio of the Emissions(in percent) of Least developed countries in 2001 to that in 2002?
Keep it short and to the point. 1.14. What is the ratio of the Emissions(in percent) of Burundi in 2001 to that in 2002?
Your answer should be very brief. 1.04. What is the ratio of the Emissions(in percent) of Czech Republic in 2001 to that in 2002?
Provide a short and direct response. 1.01. What is the difference between the highest and the second highest Emissions(in percent) of European Union?
Offer a very short reply. 1.55. What is the difference between the highest and the second highest Emissions(in percent) in Least developed countries?
Offer a terse response. 0.13. What is the difference between the highest and the second highest Emissions(in percent) in Burundi?
Give a very brief answer. 0.23. What is the difference between the highest and the second highest Emissions(in percent) of Czech Republic?
Keep it short and to the point. 0.01. What is the difference between the highest and the lowest Emissions(in percent) in European Union?
Your answer should be very brief. 2.8. What is the difference between the highest and the lowest Emissions(in percent) of Least developed countries?
Provide a succinct answer. 2.48. What is the difference between the highest and the lowest Emissions(in percent) of Burundi?
Your response must be concise. 3.72. What is the difference between the highest and the lowest Emissions(in percent) in Czech Republic?
Keep it short and to the point. 4.62. 